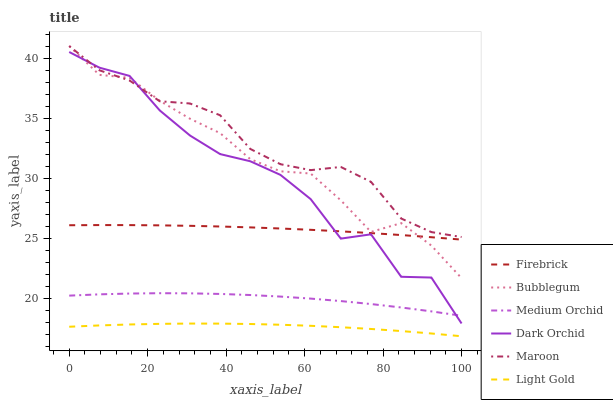Does Light Gold have the minimum area under the curve?
Answer yes or no. Yes. Does Maroon have the maximum area under the curve?
Answer yes or no. Yes. Does Firebrick have the minimum area under the curve?
Answer yes or no. No. Does Firebrick have the maximum area under the curve?
Answer yes or no. No. Is Firebrick the smoothest?
Answer yes or no. Yes. Is Dark Orchid the roughest?
Answer yes or no. Yes. Is Medium Orchid the smoothest?
Answer yes or no. No. Is Medium Orchid the roughest?
Answer yes or no. No. Does Light Gold have the lowest value?
Answer yes or no. Yes. Does Firebrick have the lowest value?
Answer yes or no. No. Does Maroon have the highest value?
Answer yes or no. Yes. Does Firebrick have the highest value?
Answer yes or no. No. Is Medium Orchid less than Firebrick?
Answer yes or no. Yes. Is Dark Orchid greater than Light Gold?
Answer yes or no. Yes. Does Maroon intersect Dark Orchid?
Answer yes or no. Yes. Is Maroon less than Dark Orchid?
Answer yes or no. No. Is Maroon greater than Dark Orchid?
Answer yes or no. No. Does Medium Orchid intersect Firebrick?
Answer yes or no. No. 